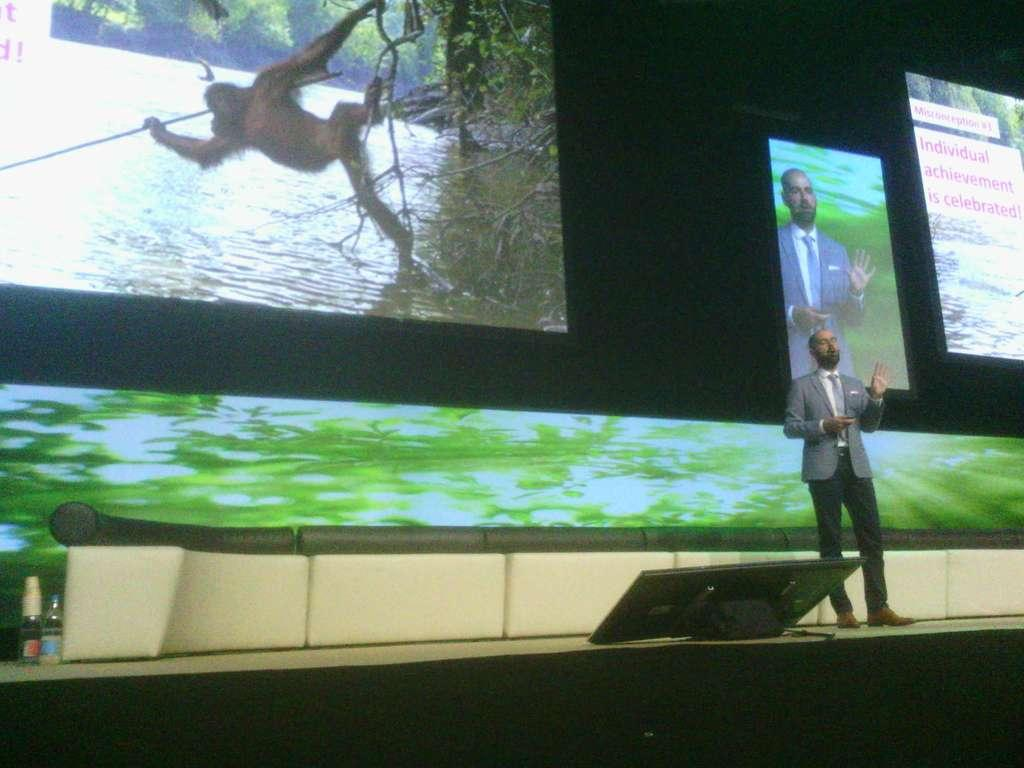What is the person in the image doing? The person is standing on the stage. What can be seen in the image besides the person on stage? There is an object, bottles, a device, and screens in the background of the image. What type of cheese is being served on the stage in the image? There is no cheese present in the image; the person is standing on the stage, and there are other items visible, but no cheese. 